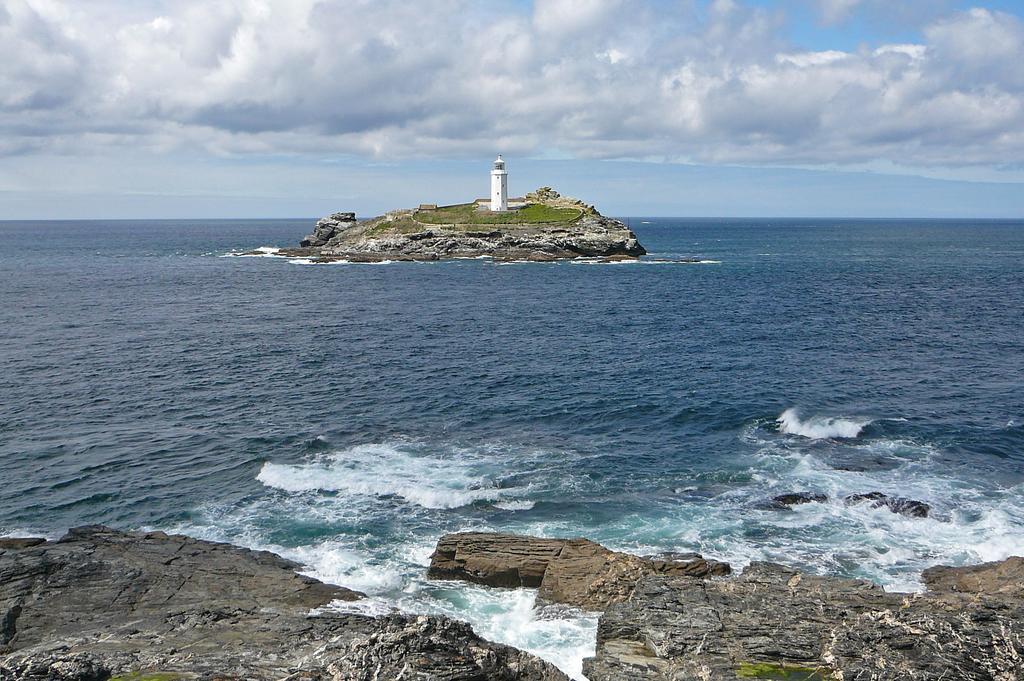How would you summarize this image in a sentence or two? In the image we can see the sea, rocks, lighthouse, grass and the cloudy sky. 